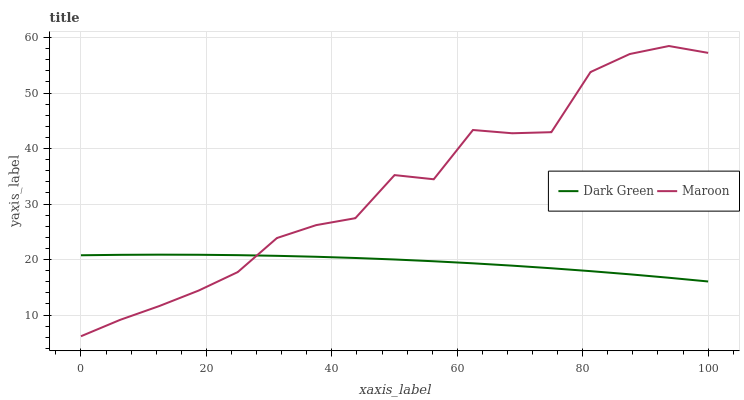Does Dark Green have the minimum area under the curve?
Answer yes or no. Yes. Does Maroon have the maximum area under the curve?
Answer yes or no. Yes. Does Dark Green have the maximum area under the curve?
Answer yes or no. No. Is Dark Green the smoothest?
Answer yes or no. Yes. Is Maroon the roughest?
Answer yes or no. Yes. Is Dark Green the roughest?
Answer yes or no. No. Does Maroon have the lowest value?
Answer yes or no. Yes. Does Dark Green have the lowest value?
Answer yes or no. No. Does Maroon have the highest value?
Answer yes or no. Yes. Does Dark Green have the highest value?
Answer yes or no. No. Does Maroon intersect Dark Green?
Answer yes or no. Yes. Is Maroon less than Dark Green?
Answer yes or no. No. Is Maroon greater than Dark Green?
Answer yes or no. No. 